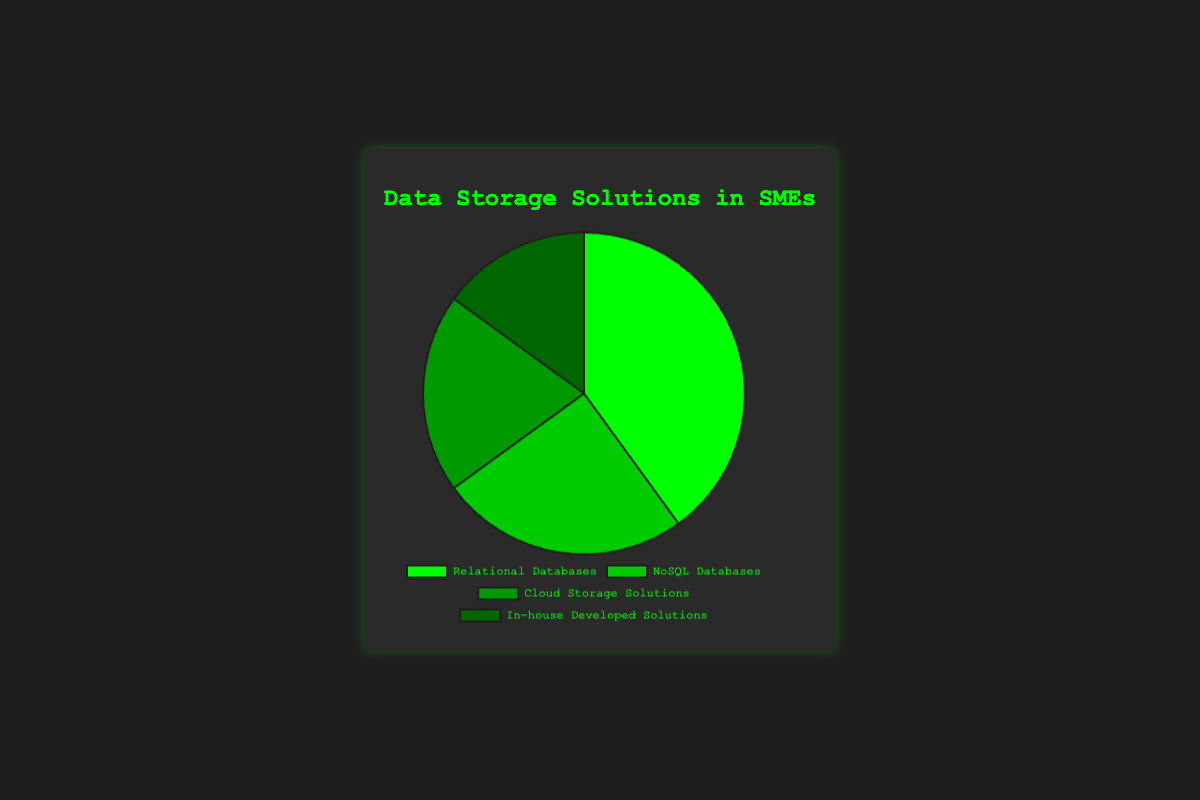What's the combined share of NoSQL Databases and In-house Developed Solutions? NoSQL Databases have a share of 25% and In-house Developed Solutions have a share of 15%. Adding these percentages together: 25% + 15% = 40%
Answer: 40% Which data storage solution has the smallest share? By looking at the percentages, In-house Developed Solutions have the smallest share at 15%
Answer: In-house Developed Solutions How much larger is the share of Relational Databases compared to Cloud Storage Solutions? Relational Databases have a share of 40%, and Cloud Storage Solutions have a share of 20%. Subtracting the share of Cloud Storage Solutions from Relational Databases: 40% - 20% = 20%
Answer: 20% What is the second most commonly used data storage solution? By comparing the shares, the second most commonly used data storage solution is NoSQL Databases at 25%
Answer: NoSQL Databases If we combine Cloud Storage Solutions and In-house Developed Solutions, how does their total share compare to Relational Databases? Cloud Storage Solutions have a share of 20% and In-house Developed Solutions have 15%, their combined share is 20% + 15% = 35%. Relational Databases have a 40% share. 40% is greater than 35%
Answer: Relational Databases have a larger share Which color represents the Cloud Storage Solutions in the pie chart? From the visual attributes, the Cloud Storage Solutions segment is colored darker green among the four colors
Answer: Darker green Are there more companies using NoSQL Databases than those using In-house Developed Solutions? Yes, NoSQL Databases have a share of 25%, which is greater than the 15% share of In-house Developed Solutions
Answer: Yes What is the total share of data storage solutions other than Relational Databases? Relational Databases account for 40%, so the remaining total share is 100% - 40% = 60%
Answer: 60% How many data storage solutions have a share of 20% or more? Relational Databases have 40%, NoSQL Databases have 25%, and Cloud Storage Solutions have 20%, making it a total of three solutions
Answer: 3 